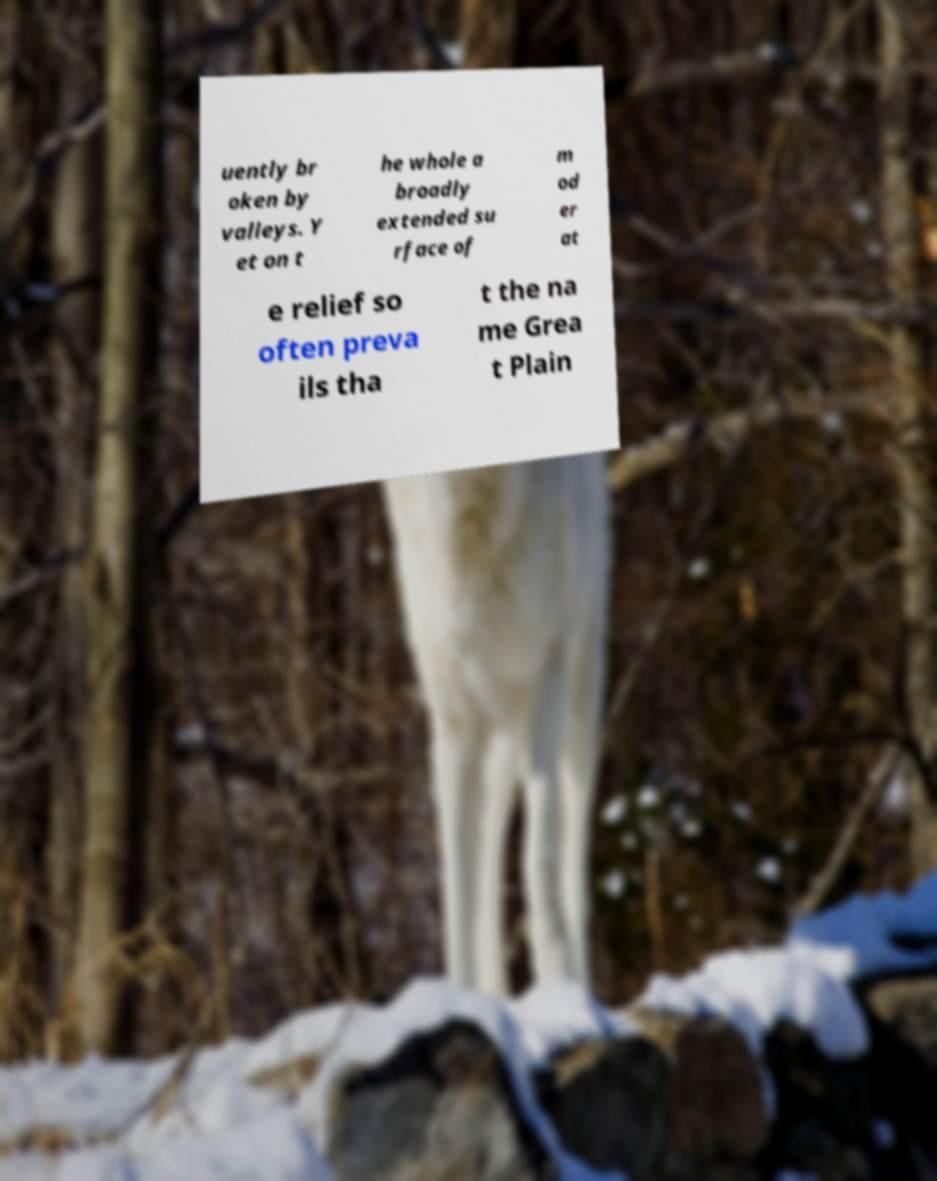Can you accurately transcribe the text from the provided image for me? uently br oken by valleys. Y et on t he whole a broadly extended su rface of m od er at e relief so often preva ils tha t the na me Grea t Plain 